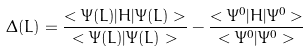Convert formula to latex. <formula><loc_0><loc_0><loc_500><loc_500>\Delta ( L ) = \frac { < \Psi ( L ) | H | \Psi ( L ) > } { < \Psi ( L ) | \Psi ( L ) > } - \frac { < \Psi ^ { 0 } | H | \Psi ^ { 0 } > } { < \Psi ^ { 0 } | \Psi ^ { 0 } > }</formula> 